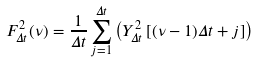Convert formula to latex. <formula><loc_0><loc_0><loc_500><loc_500>F _ { \Delta t } ^ { 2 } ( \nu ) = \frac { 1 } { \Delta t } \sum _ { j = 1 } ^ { \Delta t } \left ( Y _ { \Delta t } ^ { 2 } \left [ ( \nu - 1 ) \Delta t + j \right ] \right )</formula> 